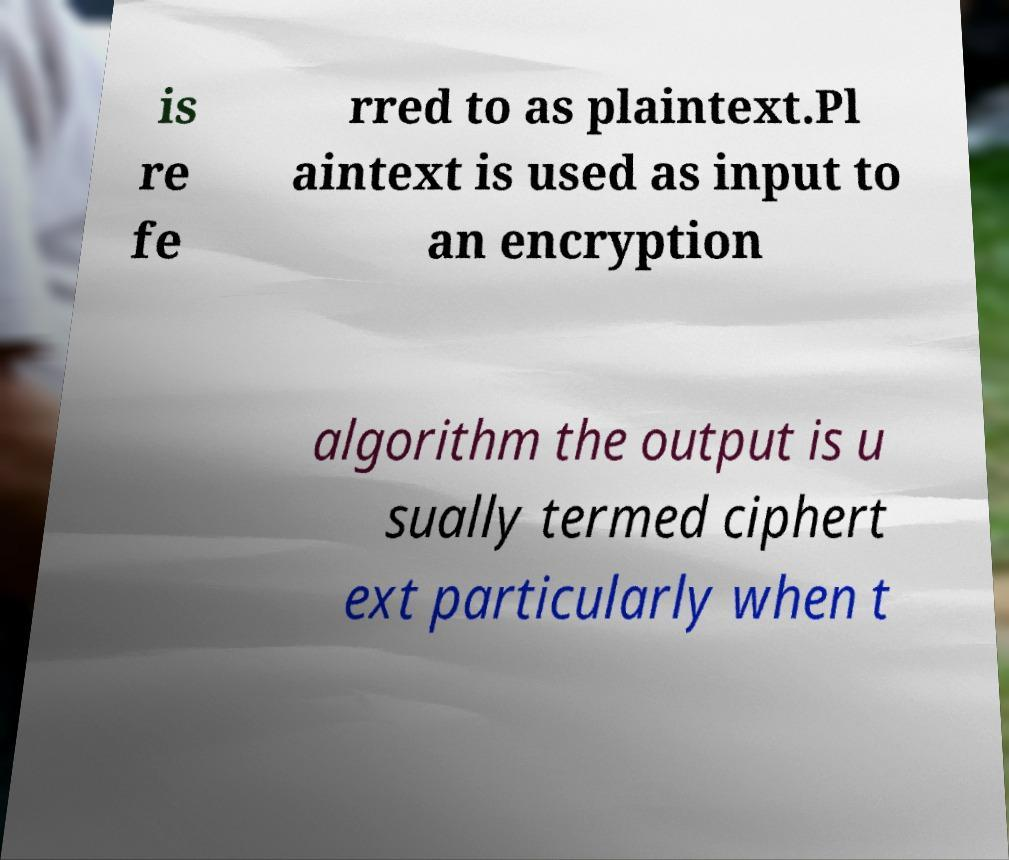Please identify and transcribe the text found in this image. is re fe rred to as plaintext.Pl aintext is used as input to an encryption algorithm the output is u sually termed ciphert ext particularly when t 